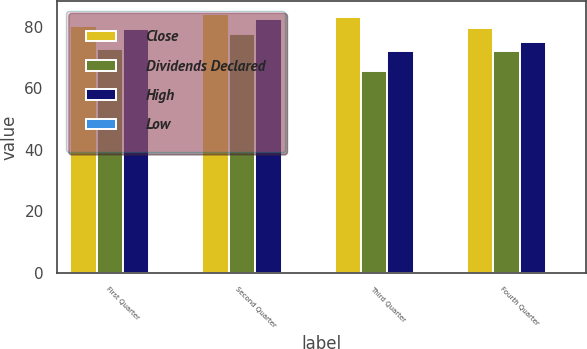<chart> <loc_0><loc_0><loc_500><loc_500><stacked_bar_chart><ecel><fcel>First Quarter<fcel>Second Quarter<fcel>Third Quarter<fcel>Fourth Quarter<nl><fcel>Close<fcel>80.16<fcel>83.99<fcel>83<fcel>79.72<nl><fcel>Dividends Declared<fcel>72.74<fcel>77.55<fcel>65.5<fcel>71.95<nl><fcel>High<fcel>79.38<fcel>82.33<fcel>71.94<fcel>74.98<nl><fcel>Low<fcel>0.38<fcel>0.38<fcel>0.38<fcel>0.38<nl></chart> 